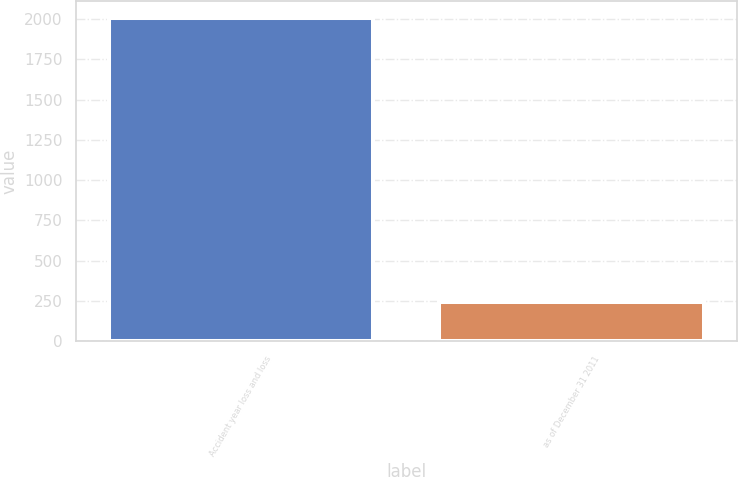<chart> <loc_0><loc_0><loc_500><loc_500><bar_chart><fcel>Accident year loss and loss<fcel>as of December 31 2011<nl><fcel>2010<fcel>241<nl></chart> 